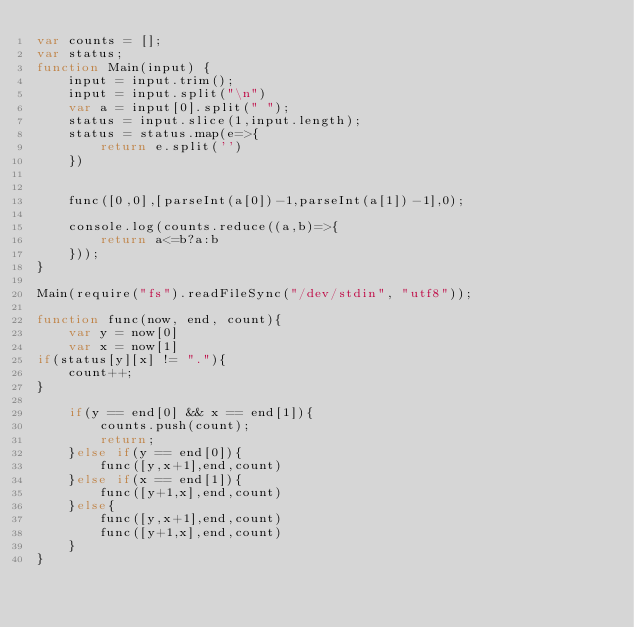<code> <loc_0><loc_0><loc_500><loc_500><_JavaScript_>var counts = [];
var status;
function Main(input) {
    input = input.trim();
    input = input.split("\n")
    var a = input[0].split(" ");
    status = input.slice(1,input.length);    
    status = status.map(e=>{
        return e.split('')
    })

    
    func([0,0],[parseInt(a[0])-1,parseInt(a[1])-1],0);

    console.log(counts.reduce((a,b)=>{
        return a<=b?a:b
    }));
}

Main(require("fs").readFileSync("/dev/stdin", "utf8")); 

function func(now, end, count){
    var y = now[0]
    var x = now[1]    
if(status[y][x] != "."){        
    count++;
}

    if(y == end[0] && x == end[1]){
        counts.push(count);
        return;
    }else if(y == end[0]){
        func([y,x+1],end,count)
    }else if(x == end[1]){
        func([y+1,x],end,count)
    }else{
        func([y,x+1],end,count)
        func([y+1,x],end,count)
    }    
}</code> 